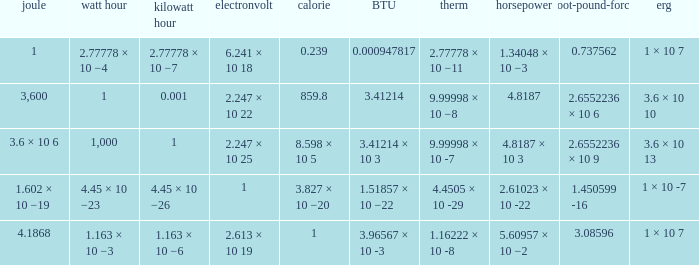How many electronvolts is 3,600 joules? 2.247 × 10 22. 